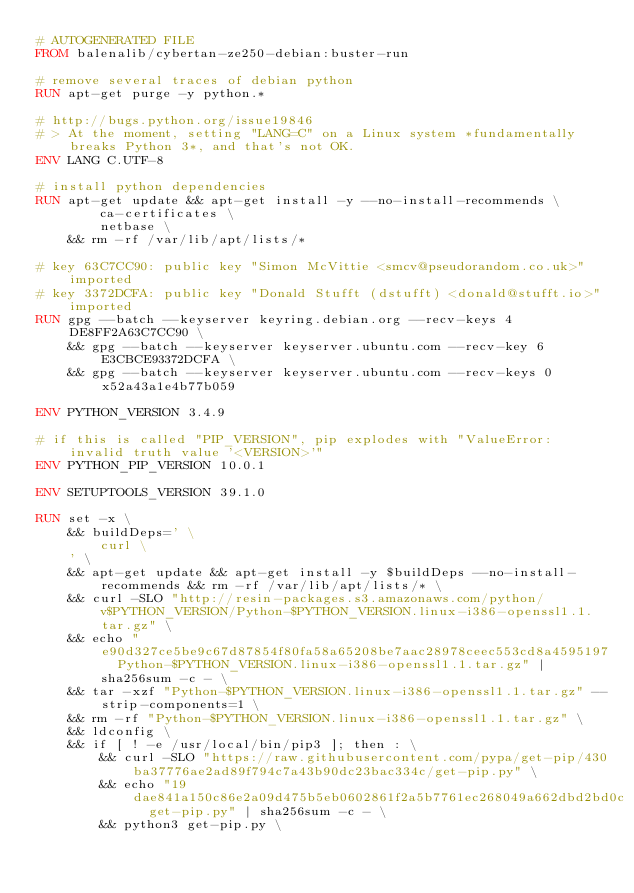Convert code to text. <code><loc_0><loc_0><loc_500><loc_500><_Dockerfile_># AUTOGENERATED FILE
FROM balenalib/cybertan-ze250-debian:buster-run

# remove several traces of debian python
RUN apt-get purge -y python.*

# http://bugs.python.org/issue19846
# > At the moment, setting "LANG=C" on a Linux system *fundamentally breaks Python 3*, and that's not OK.
ENV LANG C.UTF-8

# install python dependencies
RUN apt-get update && apt-get install -y --no-install-recommends \
		ca-certificates \
		netbase \
	&& rm -rf /var/lib/apt/lists/*

# key 63C7CC90: public key "Simon McVittie <smcv@pseudorandom.co.uk>" imported
# key 3372DCFA: public key "Donald Stufft (dstufft) <donald@stufft.io>" imported
RUN gpg --batch --keyserver keyring.debian.org --recv-keys 4DE8FF2A63C7CC90 \
	&& gpg --batch --keyserver keyserver.ubuntu.com --recv-key 6E3CBCE93372DCFA \
	&& gpg --batch --keyserver keyserver.ubuntu.com --recv-keys 0x52a43a1e4b77b059

ENV PYTHON_VERSION 3.4.9

# if this is called "PIP_VERSION", pip explodes with "ValueError: invalid truth value '<VERSION>'"
ENV PYTHON_PIP_VERSION 10.0.1

ENV SETUPTOOLS_VERSION 39.1.0

RUN set -x \
	&& buildDeps=' \
		curl \
	' \
	&& apt-get update && apt-get install -y $buildDeps --no-install-recommends && rm -rf /var/lib/apt/lists/* \
	&& curl -SLO "http://resin-packages.s3.amazonaws.com/python/v$PYTHON_VERSION/Python-$PYTHON_VERSION.linux-i386-openssl1.1.tar.gz" \
	&& echo "e90d327ce5be9c67d87854f80fa58a65208be7aac28978ceec553cd8a4595197  Python-$PYTHON_VERSION.linux-i386-openssl1.1.tar.gz" | sha256sum -c - \
	&& tar -xzf "Python-$PYTHON_VERSION.linux-i386-openssl1.1.tar.gz" --strip-components=1 \
	&& rm -rf "Python-$PYTHON_VERSION.linux-i386-openssl1.1.tar.gz" \
	&& ldconfig \
	&& if [ ! -e /usr/local/bin/pip3 ]; then : \
		&& curl -SLO "https://raw.githubusercontent.com/pypa/get-pip/430ba37776ae2ad89f794c7a43b90dc23bac334c/get-pip.py" \
		&& echo "19dae841a150c86e2a09d475b5eb0602861f2a5b7761ec268049a662dbd2bd0c  get-pip.py" | sha256sum -c - \
		&& python3 get-pip.py \</code> 